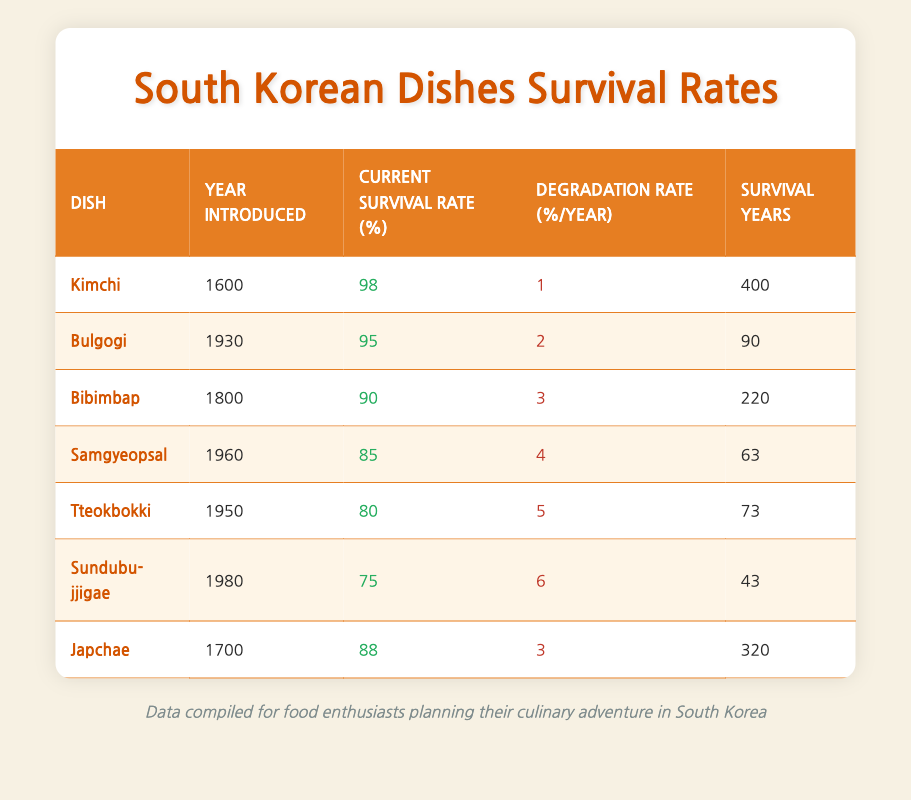What is the current survival rate of Kimchi? From the table, the current survival rate of Kimchi is listed under the "Current Survival Rate (%)" column corresponding to Kimchi. It shows a value of 98.
Answer: 98 Which dish has the highest degradation rate? To find the dish with the highest degradation rate, I will compare all the values in the "Degradation Rate (%/year)" column. The highest value is for Sundubu-jjigae at 6%.
Answer: Sundubu-jjigae What year was Bulgogi introduced? Looking at the table, the year Bulgogi was introduced is found directly in the "Year Introduced" column next to Bulgogi, which is 1930.
Answer: 1930 What is the average current survival rate of the dishes listed in the table? I will sum up the current survival rates of all dishes: (98 + 95 + 90 + 85 + 80 + 75 + 88) = 511. There are 7 dishes, so the average is 511/7 ≈ 73.14.
Answer: 73.14 Is the current survival rate of Tteokbokki greater than 80? I check the current survival rate of Tteokbokki in the table, which is 80. Since 80 is not greater than 80, the answer is false.
Answer: No Which dishes have a survival rate below 85 percent? Examine the "Current Survival Rate (%)" column for dishes below 85 percent. Samgyeopsal (85), Tteokbokki (80), and Sundubu-jjigae (75) fall below this, so we focus on Tteokbokki and Sundubu-jjigae.
Answer: Tteokbokki, Sundubu-jjigae During which year was Japchae introduced? The year Japchae was introduced can be found in the "Year Introduced" column in the row corresponding to Japchae, which states 1700.
Answer: 1700 What is the survival years of Bibimbap? I find the "Survival Years" column for Bibimbap in the table, which shows this dish has a survival span of 220 years.
Answer: 220 Does Kimchi have a lower survival rate than Bibimbap? Comparing the current survival rates in the table, Kimchi (98%) is higher than Bibimbap (90%). Therefore, the statement is false.
Answer: No 